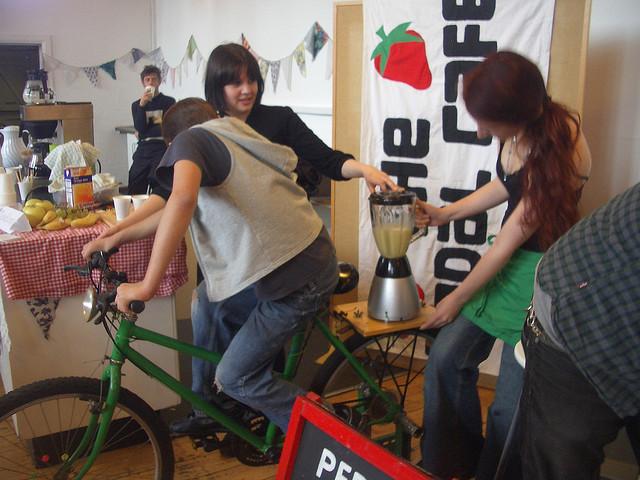How many spokes are on the rear bike wheel?
Answer briefly. 4. Did the man take off his shoes?
Answer briefly. No. Is the boy on a pedal bike?
Give a very brief answer. Yes. What color is the bike?
Give a very brief answer. Green. What is the man riding?
Write a very short answer. Bike. Is this a farmer's market?
Be succinct. No. What color is the woman's apron?
Keep it brief. Green. What color is the mixture inside the blender?
Give a very brief answer. Yellow. 